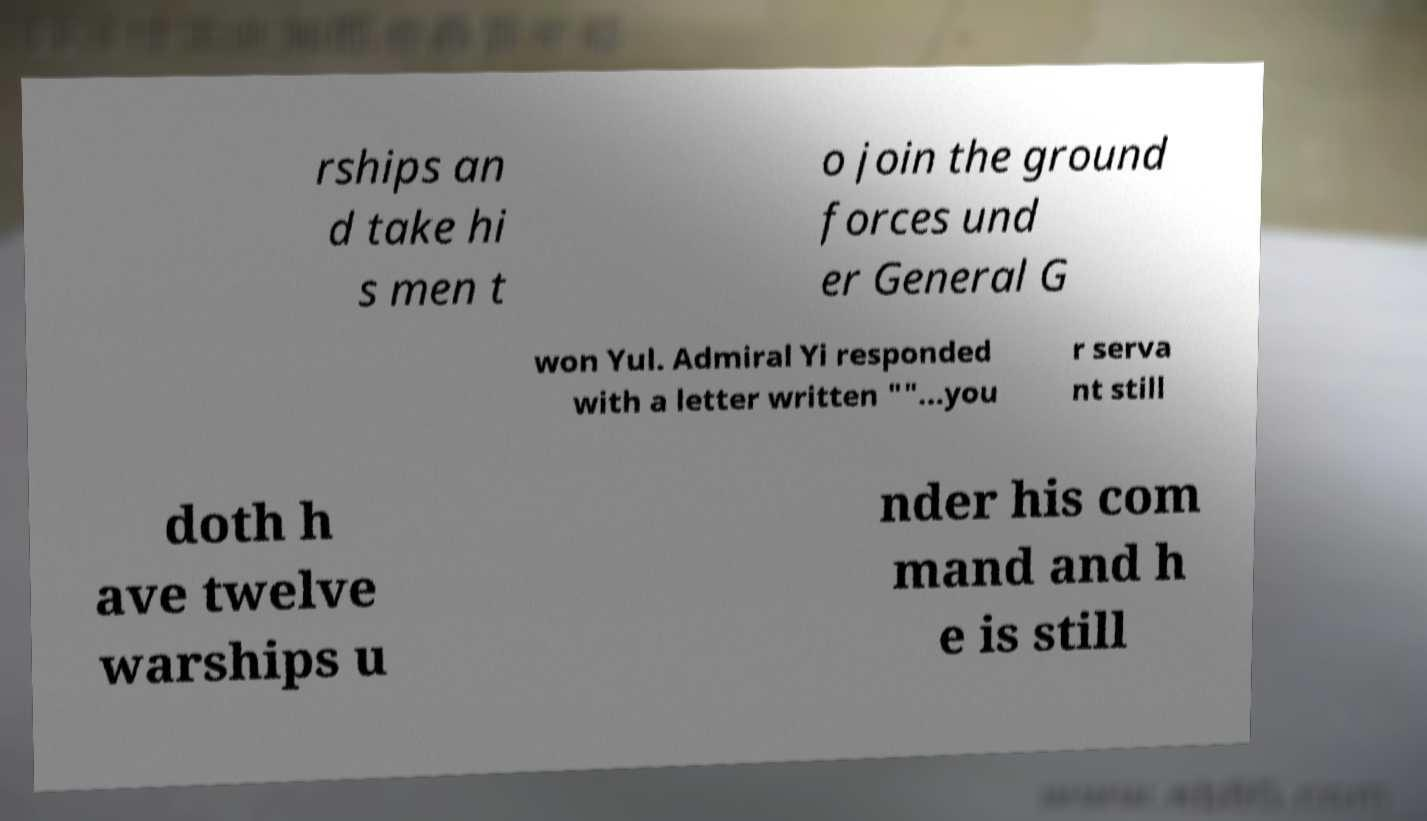Please identify and transcribe the text found in this image. rships an d take hi s men t o join the ground forces und er General G won Yul. Admiral Yi responded with a letter written ""...you r serva nt still doth h ave twelve warships u nder his com mand and h e is still 